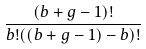<formula> <loc_0><loc_0><loc_500><loc_500>\frac { ( b + g - 1 ) ! } { b ! ( ( b + g - 1 ) - b ) ! }</formula> 